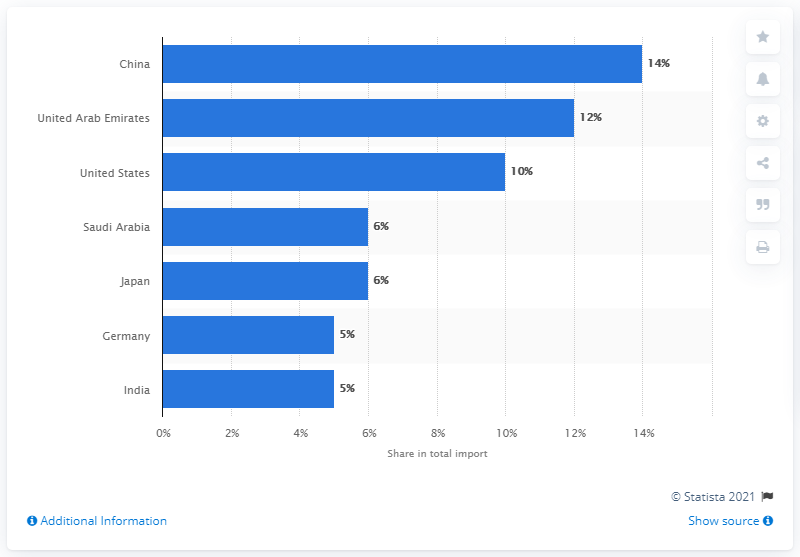Outline some significant characteristics in this image. In 2019, China was Kuwait's most important import partner. 